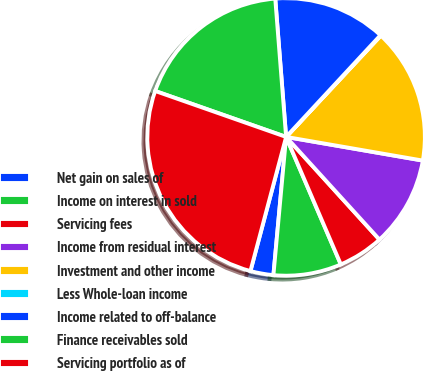Convert chart to OTSL. <chart><loc_0><loc_0><loc_500><loc_500><pie_chart><fcel>Net gain on sales of<fcel>Income on interest in sold<fcel>Servicing fees<fcel>Income from residual interest<fcel>Investment and other income<fcel>Less Whole-loan income<fcel>Income related to off-balance<fcel>Finance receivables sold<fcel>Servicing portfolio as of<nl><fcel>2.68%<fcel>7.91%<fcel>5.29%<fcel>10.53%<fcel>15.76%<fcel>0.06%<fcel>13.15%<fcel>18.38%<fcel>26.23%<nl></chart> 